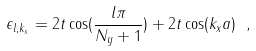Convert formula to latex. <formula><loc_0><loc_0><loc_500><loc_500>\epsilon _ { l , k _ { x } } = 2 t \cos ( \frac { l \pi } { N _ { y } + 1 } ) + 2 t \cos ( k _ { x } a ) \ ,</formula> 